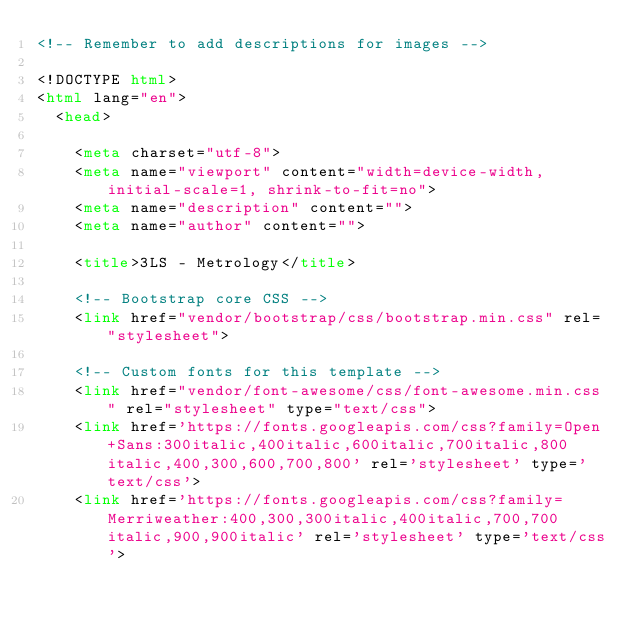<code> <loc_0><loc_0><loc_500><loc_500><_HTML_><!-- Remember to add descriptions for images -->

<!DOCTYPE html>
<html lang="en">
  <head>

    <meta charset="utf-8">
    <meta name="viewport" content="width=device-width, initial-scale=1, shrink-to-fit=no">
    <meta name="description" content="">
    <meta name="author" content="">

    <title>3LS - Metrology</title>

    <!-- Bootstrap core CSS -->
    <link href="vendor/bootstrap/css/bootstrap.min.css" rel="stylesheet">

    <!-- Custom fonts for this template -->
    <link href="vendor/font-awesome/css/font-awesome.min.css" rel="stylesheet" type="text/css">
    <link href='https://fonts.googleapis.com/css?family=Open+Sans:300italic,400italic,600italic,700italic,800italic,400,300,600,700,800' rel='stylesheet' type='text/css'>
    <link href='https://fonts.googleapis.com/css?family=Merriweather:400,300,300italic,400italic,700,700italic,900,900italic' rel='stylesheet' type='text/css'>
</code> 